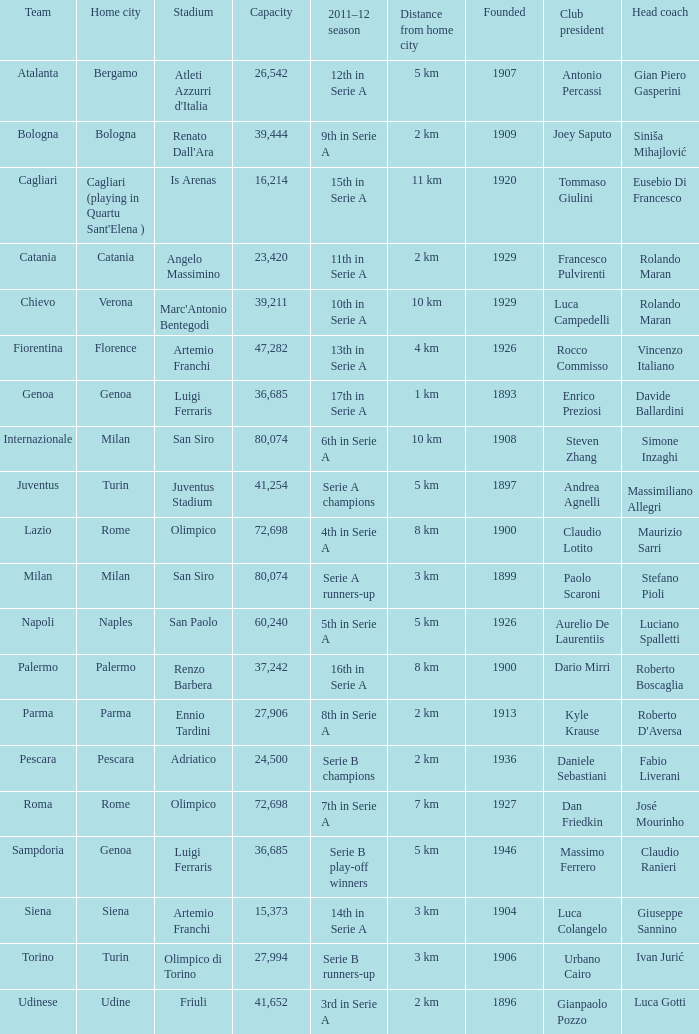Would you mind parsing the complete table? {'header': ['Team', 'Home city', 'Stadium', 'Capacity', '2011–12 season', 'Distance from home city', 'Founded', 'Club president', 'Head coach'], 'rows': [['Atalanta', 'Bergamo', "Atleti Azzurri d'Italia", '26,542', '12th in Serie A', '5 km', '1907', 'Antonio Percassi', 'Gian Piero Gasperini'], ['Bologna', 'Bologna', "Renato Dall'Ara", '39,444', '9th in Serie A', '2 km', '1909', 'Joey Saputo', 'Siniša Mihajlović'], ['Cagliari', "Cagliari (playing in Quartu Sant'Elena )", 'Is Arenas', '16,214', '15th in Serie A', '11 km', '1920', 'Tommaso Giulini', 'Eusebio Di Francesco'], ['Catania', 'Catania', 'Angelo Massimino', '23,420', '11th in Serie A', '2 km', '1929', 'Francesco Pulvirenti', 'Rolando Maran'], ['Chievo', 'Verona', "Marc'Antonio Bentegodi", '39,211', '10th in Serie A', '10 km', '1929', 'Luca Campedelli', 'Rolando Maran'], ['Fiorentina', 'Florence', 'Artemio Franchi', '47,282', '13th in Serie A', '4 km', '1926', 'Rocco Commisso', 'Vincenzo Italiano'], ['Genoa', 'Genoa', 'Luigi Ferraris', '36,685', '17th in Serie A', '1 km', '1893', 'Enrico Preziosi', 'Davide Ballardini'], ['Internazionale', 'Milan', 'San Siro', '80,074', '6th in Serie A', '10 km', '1908', 'Steven Zhang', 'Simone Inzaghi'], ['Juventus', 'Turin', 'Juventus Stadium', '41,254', 'Serie A champions', '5 km', '1897', 'Andrea Agnelli', 'Massimiliano Allegri'], ['Lazio', 'Rome', 'Olimpico', '72,698', '4th in Serie A', '8 km', '1900', 'Claudio Lotito', 'Maurizio Sarri'], ['Milan', 'Milan', 'San Siro', '80,074', 'Serie A runners-up', '3 km', '1899', 'Paolo Scaroni', 'Stefano Pioli'], ['Napoli', 'Naples', 'San Paolo', '60,240', '5th in Serie A', '5 km', '1926', 'Aurelio De Laurentiis', 'Luciano Spalletti'], ['Palermo', 'Palermo', 'Renzo Barbera', '37,242', '16th in Serie A', '8 km', '1900', 'Dario Mirri', 'Roberto Boscaglia'], ['Parma', 'Parma', 'Ennio Tardini', '27,906', '8th in Serie A', '2 km', '1913', 'Kyle Krause', "Roberto D'Aversa"], ['Pescara', 'Pescara', 'Adriatico', '24,500', 'Serie B champions', '2 km', '1936', 'Daniele Sebastiani', 'Fabio Liverani'], ['Roma', 'Rome', 'Olimpico', '72,698', '7th in Serie A', '7 km', '1927', 'Dan Friedkin', 'José Mourinho'], ['Sampdoria', 'Genoa', 'Luigi Ferraris', '36,685', 'Serie B play-off winners', '5 km', '1946', 'Massimo Ferrero', 'Claudio Ranieri'], ['Siena', 'Siena', 'Artemio Franchi', '15,373', '14th in Serie A', '3 km', '1904', 'Luca Colangelo', 'Giuseppe Sannino'], ['Torino', 'Turin', 'Olimpico di Torino', '27,994', 'Serie B runners-up', '3 km', '1906', 'Urbano Cairo', 'Ivan Jurić'], ['Udinese', 'Udine', 'Friuli', '41,652', '3rd in Serie A', '2 km', '1896', 'Gianpaolo Pozzo', 'Luca Gotti']]} What is the home city for angelo massimino stadium? Catania. 